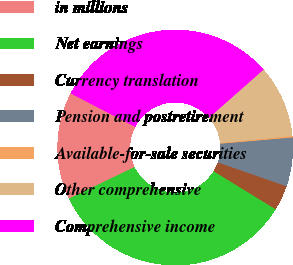Convert chart. <chart><loc_0><loc_0><loc_500><loc_500><pie_chart><fcel>in millions<fcel>Net earnings<fcel>Currency translation<fcel>Pension and postretirement<fcel>Available-for-sale securities<fcel>Other comprehensive<fcel>Comprehensive income<nl><fcel>14.74%<fcel>34.11%<fcel>3.45%<fcel>6.69%<fcel>0.22%<fcel>9.92%<fcel>30.87%<nl></chart> 